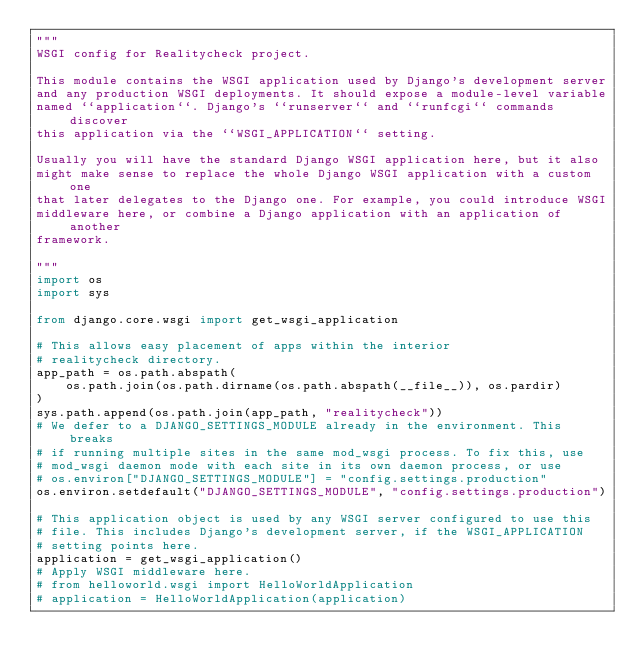Convert code to text. <code><loc_0><loc_0><loc_500><loc_500><_Python_>"""
WSGI config for Realitycheck project.

This module contains the WSGI application used by Django's development server
and any production WSGI deployments. It should expose a module-level variable
named ``application``. Django's ``runserver`` and ``runfcgi`` commands discover
this application via the ``WSGI_APPLICATION`` setting.

Usually you will have the standard Django WSGI application here, but it also
might make sense to replace the whole Django WSGI application with a custom one
that later delegates to the Django one. For example, you could introduce WSGI
middleware here, or combine a Django application with an application of another
framework.

"""
import os
import sys

from django.core.wsgi import get_wsgi_application

# This allows easy placement of apps within the interior
# realitycheck directory.
app_path = os.path.abspath(
    os.path.join(os.path.dirname(os.path.abspath(__file__)), os.pardir)
)
sys.path.append(os.path.join(app_path, "realitycheck"))
# We defer to a DJANGO_SETTINGS_MODULE already in the environment. This breaks
# if running multiple sites in the same mod_wsgi process. To fix this, use
# mod_wsgi daemon mode with each site in its own daemon process, or use
# os.environ["DJANGO_SETTINGS_MODULE"] = "config.settings.production"
os.environ.setdefault("DJANGO_SETTINGS_MODULE", "config.settings.production")

# This application object is used by any WSGI server configured to use this
# file. This includes Django's development server, if the WSGI_APPLICATION
# setting points here.
application = get_wsgi_application()
# Apply WSGI middleware here.
# from helloworld.wsgi import HelloWorldApplication
# application = HelloWorldApplication(application)
</code> 